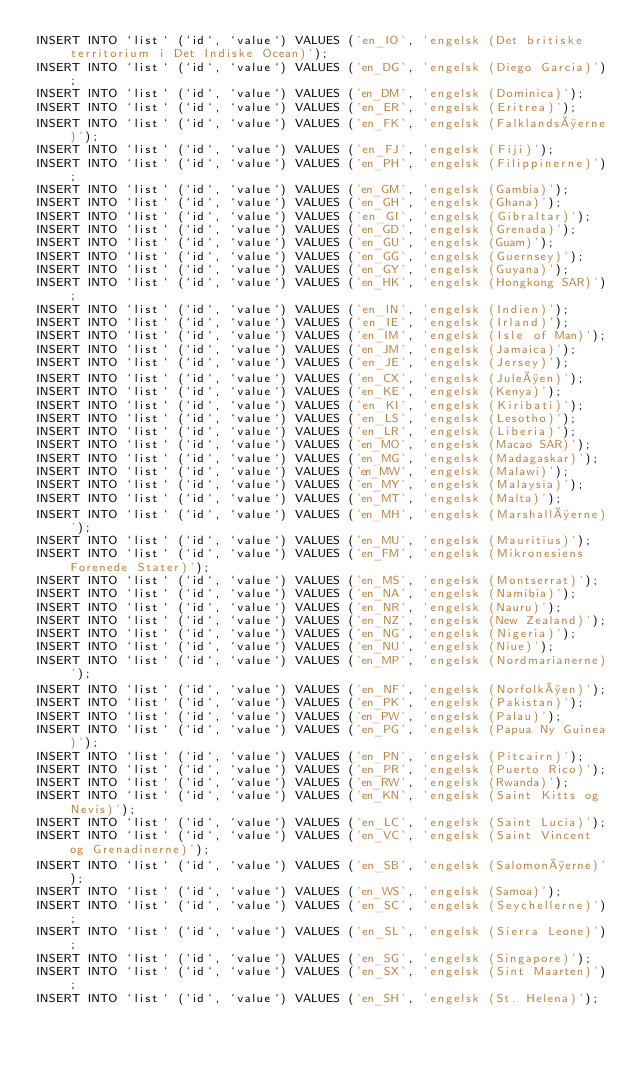Convert code to text. <code><loc_0><loc_0><loc_500><loc_500><_SQL_>INSERT INTO `list` (`id`, `value`) VALUES ('en_IO', 'engelsk (Det britiske territorium i Det Indiske Ocean)');
INSERT INTO `list` (`id`, `value`) VALUES ('en_DG', 'engelsk (Diego Garcia)');
INSERT INTO `list` (`id`, `value`) VALUES ('en_DM', 'engelsk (Dominica)');
INSERT INTO `list` (`id`, `value`) VALUES ('en_ER', 'engelsk (Eritrea)');
INSERT INTO `list` (`id`, `value`) VALUES ('en_FK', 'engelsk (Falklandsøerne)');
INSERT INTO `list` (`id`, `value`) VALUES ('en_FJ', 'engelsk (Fiji)');
INSERT INTO `list` (`id`, `value`) VALUES ('en_PH', 'engelsk (Filippinerne)');
INSERT INTO `list` (`id`, `value`) VALUES ('en_GM', 'engelsk (Gambia)');
INSERT INTO `list` (`id`, `value`) VALUES ('en_GH', 'engelsk (Ghana)');
INSERT INTO `list` (`id`, `value`) VALUES ('en_GI', 'engelsk (Gibraltar)');
INSERT INTO `list` (`id`, `value`) VALUES ('en_GD', 'engelsk (Grenada)');
INSERT INTO `list` (`id`, `value`) VALUES ('en_GU', 'engelsk (Guam)');
INSERT INTO `list` (`id`, `value`) VALUES ('en_GG', 'engelsk (Guernsey)');
INSERT INTO `list` (`id`, `value`) VALUES ('en_GY', 'engelsk (Guyana)');
INSERT INTO `list` (`id`, `value`) VALUES ('en_HK', 'engelsk (Hongkong SAR)');
INSERT INTO `list` (`id`, `value`) VALUES ('en_IN', 'engelsk (Indien)');
INSERT INTO `list` (`id`, `value`) VALUES ('en_IE', 'engelsk (Irland)');
INSERT INTO `list` (`id`, `value`) VALUES ('en_IM', 'engelsk (Isle of Man)');
INSERT INTO `list` (`id`, `value`) VALUES ('en_JM', 'engelsk (Jamaica)');
INSERT INTO `list` (`id`, `value`) VALUES ('en_JE', 'engelsk (Jersey)');
INSERT INTO `list` (`id`, `value`) VALUES ('en_CX', 'engelsk (Juleøen)');
INSERT INTO `list` (`id`, `value`) VALUES ('en_KE', 'engelsk (Kenya)');
INSERT INTO `list` (`id`, `value`) VALUES ('en_KI', 'engelsk (Kiribati)');
INSERT INTO `list` (`id`, `value`) VALUES ('en_LS', 'engelsk (Lesotho)');
INSERT INTO `list` (`id`, `value`) VALUES ('en_LR', 'engelsk (Liberia)');
INSERT INTO `list` (`id`, `value`) VALUES ('en_MO', 'engelsk (Macao SAR)');
INSERT INTO `list` (`id`, `value`) VALUES ('en_MG', 'engelsk (Madagaskar)');
INSERT INTO `list` (`id`, `value`) VALUES ('en_MW', 'engelsk (Malawi)');
INSERT INTO `list` (`id`, `value`) VALUES ('en_MY', 'engelsk (Malaysia)');
INSERT INTO `list` (`id`, `value`) VALUES ('en_MT', 'engelsk (Malta)');
INSERT INTO `list` (`id`, `value`) VALUES ('en_MH', 'engelsk (Marshalløerne)');
INSERT INTO `list` (`id`, `value`) VALUES ('en_MU', 'engelsk (Mauritius)');
INSERT INTO `list` (`id`, `value`) VALUES ('en_FM', 'engelsk (Mikronesiens Forenede Stater)');
INSERT INTO `list` (`id`, `value`) VALUES ('en_MS', 'engelsk (Montserrat)');
INSERT INTO `list` (`id`, `value`) VALUES ('en_NA', 'engelsk (Namibia)');
INSERT INTO `list` (`id`, `value`) VALUES ('en_NR', 'engelsk (Nauru)');
INSERT INTO `list` (`id`, `value`) VALUES ('en_NZ', 'engelsk (New Zealand)');
INSERT INTO `list` (`id`, `value`) VALUES ('en_NG', 'engelsk (Nigeria)');
INSERT INTO `list` (`id`, `value`) VALUES ('en_NU', 'engelsk (Niue)');
INSERT INTO `list` (`id`, `value`) VALUES ('en_MP', 'engelsk (Nordmarianerne)');
INSERT INTO `list` (`id`, `value`) VALUES ('en_NF', 'engelsk (Norfolkøen)');
INSERT INTO `list` (`id`, `value`) VALUES ('en_PK', 'engelsk (Pakistan)');
INSERT INTO `list` (`id`, `value`) VALUES ('en_PW', 'engelsk (Palau)');
INSERT INTO `list` (`id`, `value`) VALUES ('en_PG', 'engelsk (Papua Ny Guinea)');
INSERT INTO `list` (`id`, `value`) VALUES ('en_PN', 'engelsk (Pitcairn)');
INSERT INTO `list` (`id`, `value`) VALUES ('en_PR', 'engelsk (Puerto Rico)');
INSERT INTO `list` (`id`, `value`) VALUES ('en_RW', 'engelsk (Rwanda)');
INSERT INTO `list` (`id`, `value`) VALUES ('en_KN', 'engelsk (Saint Kitts og Nevis)');
INSERT INTO `list` (`id`, `value`) VALUES ('en_LC', 'engelsk (Saint Lucia)');
INSERT INTO `list` (`id`, `value`) VALUES ('en_VC', 'engelsk (Saint Vincent og Grenadinerne)');
INSERT INTO `list` (`id`, `value`) VALUES ('en_SB', 'engelsk (Salomonøerne)');
INSERT INTO `list` (`id`, `value`) VALUES ('en_WS', 'engelsk (Samoa)');
INSERT INTO `list` (`id`, `value`) VALUES ('en_SC', 'engelsk (Seychellerne)');
INSERT INTO `list` (`id`, `value`) VALUES ('en_SL', 'engelsk (Sierra Leone)');
INSERT INTO `list` (`id`, `value`) VALUES ('en_SG', 'engelsk (Singapore)');
INSERT INTO `list` (`id`, `value`) VALUES ('en_SX', 'engelsk (Sint Maarten)');
INSERT INTO `list` (`id`, `value`) VALUES ('en_SH', 'engelsk (St. Helena)');</code> 